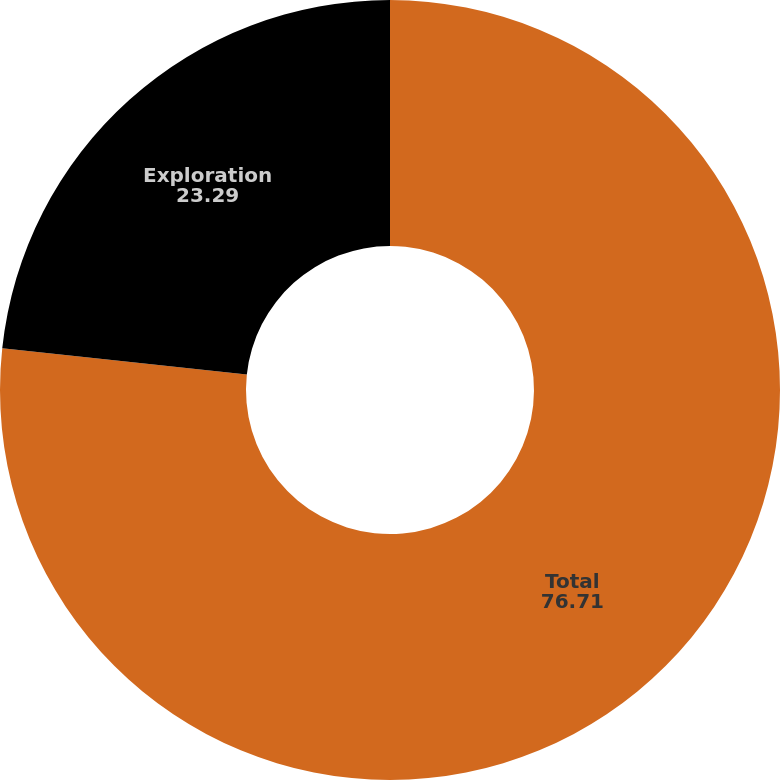<chart> <loc_0><loc_0><loc_500><loc_500><pie_chart><fcel>Total<fcel>Exploration<nl><fcel>76.71%<fcel>23.29%<nl></chart> 